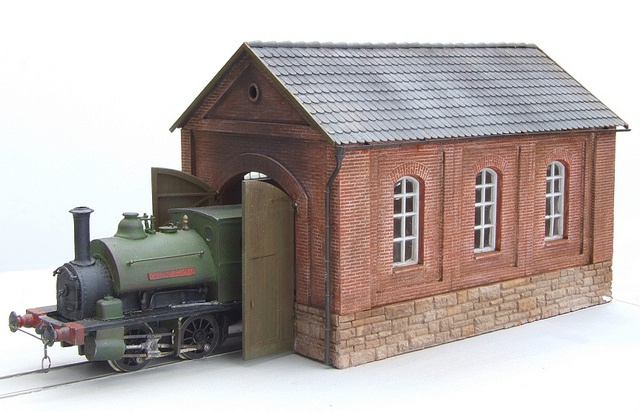Describe the objects in this image and their specific colors. I can see a train in white, gray, black, and darkgray tones in this image. 